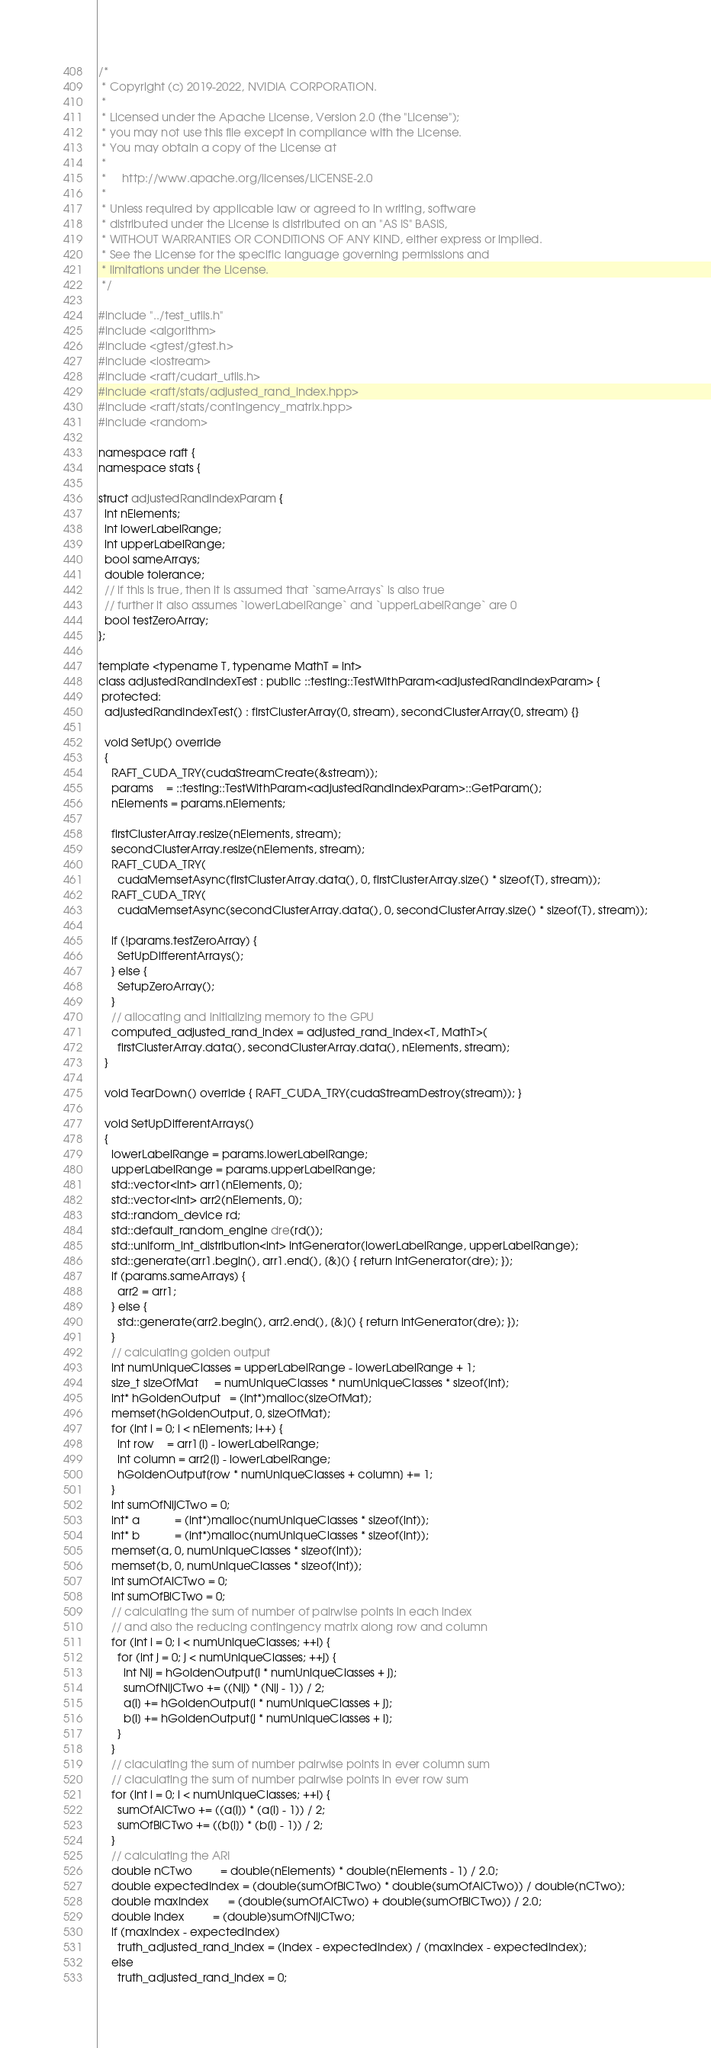Convert code to text. <code><loc_0><loc_0><loc_500><loc_500><_Cuda_>/*
 * Copyright (c) 2019-2022, NVIDIA CORPORATION.
 *
 * Licensed under the Apache License, Version 2.0 (the "License");
 * you may not use this file except in compliance with the License.
 * You may obtain a copy of the License at
 *
 *     http://www.apache.org/licenses/LICENSE-2.0
 *
 * Unless required by applicable law or agreed to in writing, software
 * distributed under the License is distributed on an "AS IS" BASIS,
 * WITHOUT WARRANTIES OR CONDITIONS OF ANY KIND, either express or implied.
 * See the License for the specific language governing permissions and
 * limitations under the License.
 */

#include "../test_utils.h"
#include <algorithm>
#include <gtest/gtest.h>
#include <iostream>
#include <raft/cudart_utils.h>
#include <raft/stats/adjusted_rand_index.hpp>
#include <raft/stats/contingency_matrix.hpp>
#include <random>

namespace raft {
namespace stats {

struct adjustedRandIndexParam {
  int nElements;
  int lowerLabelRange;
  int upperLabelRange;
  bool sameArrays;
  double tolerance;
  // if this is true, then it is assumed that `sameArrays` is also true
  // further it also assumes `lowerLabelRange` and `upperLabelRange` are 0
  bool testZeroArray;
};

template <typename T, typename MathT = int>
class adjustedRandIndexTest : public ::testing::TestWithParam<adjustedRandIndexParam> {
 protected:
  adjustedRandIndexTest() : firstClusterArray(0, stream), secondClusterArray(0, stream) {}

  void SetUp() override
  {
    RAFT_CUDA_TRY(cudaStreamCreate(&stream));
    params    = ::testing::TestWithParam<adjustedRandIndexParam>::GetParam();
    nElements = params.nElements;

    firstClusterArray.resize(nElements, stream);
    secondClusterArray.resize(nElements, stream);
    RAFT_CUDA_TRY(
      cudaMemsetAsync(firstClusterArray.data(), 0, firstClusterArray.size() * sizeof(T), stream));
    RAFT_CUDA_TRY(
      cudaMemsetAsync(secondClusterArray.data(), 0, secondClusterArray.size() * sizeof(T), stream));

    if (!params.testZeroArray) {
      SetUpDifferentArrays();
    } else {
      SetupZeroArray();
    }
    // allocating and initializing memory to the GPU
    computed_adjusted_rand_index = adjusted_rand_index<T, MathT>(
      firstClusterArray.data(), secondClusterArray.data(), nElements, stream);
  }

  void TearDown() override { RAFT_CUDA_TRY(cudaStreamDestroy(stream)); }

  void SetUpDifferentArrays()
  {
    lowerLabelRange = params.lowerLabelRange;
    upperLabelRange = params.upperLabelRange;
    std::vector<int> arr1(nElements, 0);
    std::vector<int> arr2(nElements, 0);
    std::random_device rd;
    std::default_random_engine dre(rd());
    std::uniform_int_distribution<int> intGenerator(lowerLabelRange, upperLabelRange);
    std::generate(arr1.begin(), arr1.end(), [&]() { return intGenerator(dre); });
    if (params.sameArrays) {
      arr2 = arr1;
    } else {
      std::generate(arr2.begin(), arr2.end(), [&]() { return intGenerator(dre); });
    }
    // calculating golden output
    int numUniqueClasses = upperLabelRange - lowerLabelRange + 1;
    size_t sizeOfMat     = numUniqueClasses * numUniqueClasses * sizeof(int);
    int* hGoldenOutput   = (int*)malloc(sizeOfMat);
    memset(hGoldenOutput, 0, sizeOfMat);
    for (int i = 0; i < nElements; i++) {
      int row    = arr1[i] - lowerLabelRange;
      int column = arr2[i] - lowerLabelRange;
      hGoldenOutput[row * numUniqueClasses + column] += 1;
    }
    int sumOfNijCTwo = 0;
    int* a           = (int*)malloc(numUniqueClasses * sizeof(int));
    int* b           = (int*)malloc(numUniqueClasses * sizeof(int));
    memset(a, 0, numUniqueClasses * sizeof(int));
    memset(b, 0, numUniqueClasses * sizeof(int));
    int sumOfAiCTwo = 0;
    int sumOfBiCTwo = 0;
    // calculating the sum of number of pairwise points in each index
    // and also the reducing contingency matrix along row and column
    for (int i = 0; i < numUniqueClasses; ++i) {
      for (int j = 0; j < numUniqueClasses; ++j) {
        int Nij = hGoldenOutput[i * numUniqueClasses + j];
        sumOfNijCTwo += ((Nij) * (Nij - 1)) / 2;
        a[i] += hGoldenOutput[i * numUniqueClasses + j];
        b[i] += hGoldenOutput[j * numUniqueClasses + i];
      }
    }
    // claculating the sum of number pairwise points in ever column sum
    // claculating the sum of number pairwise points in ever row sum
    for (int i = 0; i < numUniqueClasses; ++i) {
      sumOfAiCTwo += ((a[i]) * (a[i] - 1)) / 2;
      sumOfBiCTwo += ((b[i]) * (b[i] - 1)) / 2;
    }
    // calculating the ARI
    double nCTwo         = double(nElements) * double(nElements - 1) / 2.0;
    double expectedIndex = (double(sumOfBiCTwo) * double(sumOfAiCTwo)) / double(nCTwo);
    double maxIndex      = (double(sumOfAiCTwo) + double(sumOfBiCTwo)) / 2.0;
    double index         = (double)sumOfNijCTwo;
    if (maxIndex - expectedIndex)
      truth_adjusted_rand_index = (index - expectedIndex) / (maxIndex - expectedIndex);
    else
      truth_adjusted_rand_index = 0;</code> 